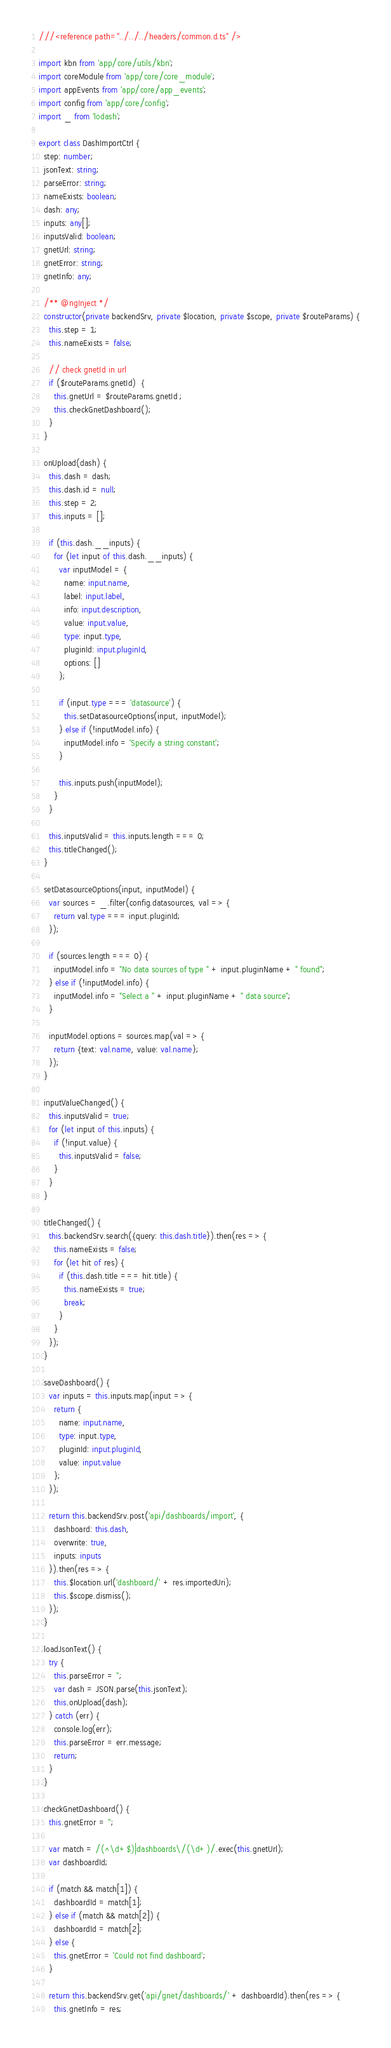Convert code to text. <code><loc_0><loc_0><loc_500><loc_500><_TypeScript_>///<reference path="../../../headers/common.d.ts" />

import kbn from 'app/core/utils/kbn';
import coreModule from 'app/core/core_module';
import appEvents from 'app/core/app_events';
import config from 'app/core/config';
import _ from 'lodash';

export class DashImportCtrl {
  step: number;
  jsonText: string;
  parseError: string;
  nameExists: boolean;
  dash: any;
  inputs: any[];
  inputsValid: boolean;
  gnetUrl: string;
  gnetError: string;
  gnetInfo: any;

  /** @ngInject */
  constructor(private backendSrv, private $location, private $scope, private $routeParams) {
    this.step = 1;
    this.nameExists = false;

    // check gnetId in url
    if ($routeParams.gnetId)  {
      this.gnetUrl = $routeParams.gnetId ;
      this.checkGnetDashboard();
    }
  }

  onUpload(dash) {
    this.dash = dash;
    this.dash.id = null;
    this.step = 2;
    this.inputs = [];

    if (this.dash.__inputs) {
      for (let input of this.dash.__inputs) {
        var inputModel = {
          name: input.name,
          label: input.label,
          info: input.description,
          value: input.value,
          type: input.type,
          pluginId: input.pluginId,
          options: []
        };

        if (input.type === 'datasource') {
          this.setDatasourceOptions(input, inputModel);
        } else if (!inputModel.info) {
          inputModel.info = 'Specify a string constant';
        }

        this.inputs.push(inputModel);
      }
    }

    this.inputsValid = this.inputs.length === 0;
    this.titleChanged();
  }

  setDatasourceOptions(input, inputModel) {
    var sources = _.filter(config.datasources, val => {
      return val.type === input.pluginId;
    });

    if (sources.length === 0) {
      inputModel.info = "No data sources of type " + input.pluginName + " found";
    } else if (!inputModel.info) {
      inputModel.info = "Select a " + input.pluginName + " data source";
    }

    inputModel.options = sources.map(val => {
      return {text: val.name, value: val.name};
    });
  }

  inputValueChanged() {
    this.inputsValid = true;
    for (let input of this.inputs) {
      if (!input.value) {
        this.inputsValid = false;
      }
    }
  }

  titleChanged() {
    this.backendSrv.search({query: this.dash.title}).then(res => {
      this.nameExists = false;
      for (let hit of res) {
        if (this.dash.title === hit.title) {
          this.nameExists = true;
          break;
        }
      }
    });
  }

  saveDashboard() {
    var inputs = this.inputs.map(input => {
      return {
        name: input.name,
        type: input.type,
        pluginId: input.pluginId,
        value: input.value
      };
    });

    return this.backendSrv.post('api/dashboards/import', {
      dashboard: this.dash,
      overwrite: true,
      inputs: inputs
    }).then(res => {
      this.$location.url('dashboard/' + res.importedUri);
      this.$scope.dismiss();
    });
  }

  loadJsonText() {
    try {
      this.parseError = '';
      var dash = JSON.parse(this.jsonText);
      this.onUpload(dash);
    } catch (err) {
      console.log(err);
      this.parseError = err.message;
      return;
    }
  }

  checkGnetDashboard() {
    this.gnetError = '';

    var match = /(^\d+$)|dashboards\/(\d+)/.exec(this.gnetUrl);
    var dashboardId;

    if (match && match[1]) {
      dashboardId = match[1];
    } else if (match && match[2]) {
      dashboardId = match[2];
    } else {
      this.gnetError = 'Could not find dashboard';
    }

    return this.backendSrv.get('api/gnet/dashboards/' + dashboardId).then(res => {
      this.gnetInfo = res;</code> 